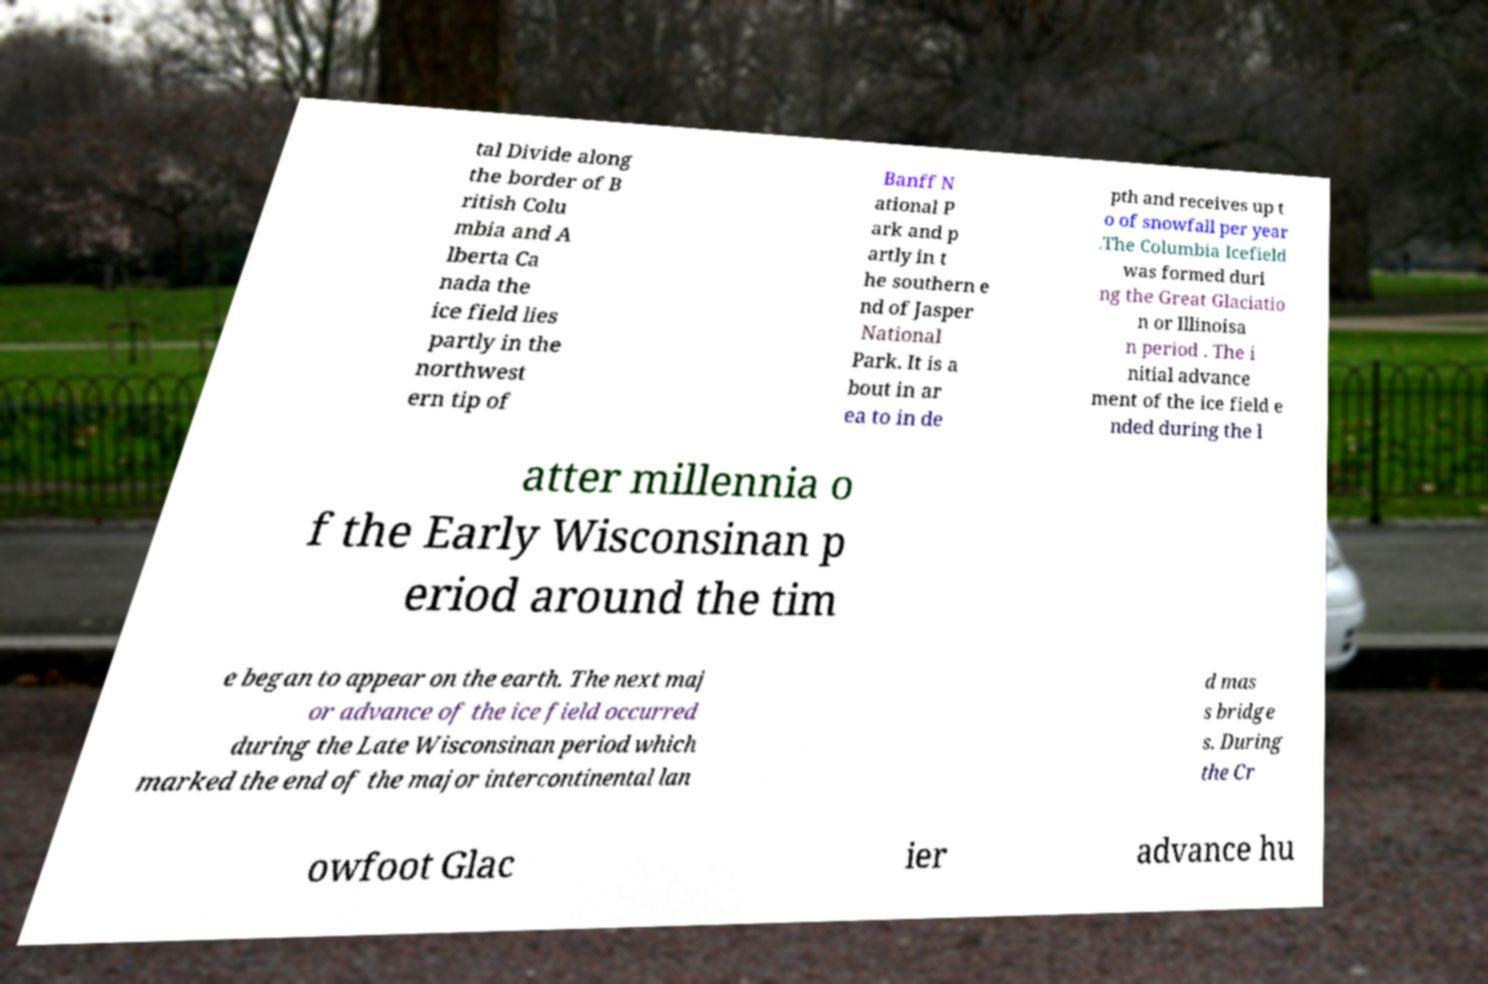Can you read and provide the text displayed in the image?This photo seems to have some interesting text. Can you extract and type it out for me? tal Divide along the border of B ritish Colu mbia and A lberta Ca nada the ice field lies partly in the northwest ern tip of Banff N ational P ark and p artly in t he southern e nd of Jasper National Park. It is a bout in ar ea to in de pth and receives up t o of snowfall per year .The Columbia Icefield was formed duri ng the Great Glaciatio n or Illinoisa n period . The i nitial advance ment of the ice field e nded during the l atter millennia o f the Early Wisconsinan p eriod around the tim e began to appear on the earth. The next maj or advance of the ice field occurred during the Late Wisconsinan period which marked the end of the major intercontinental lan d mas s bridge s. During the Cr owfoot Glac ier advance hu 